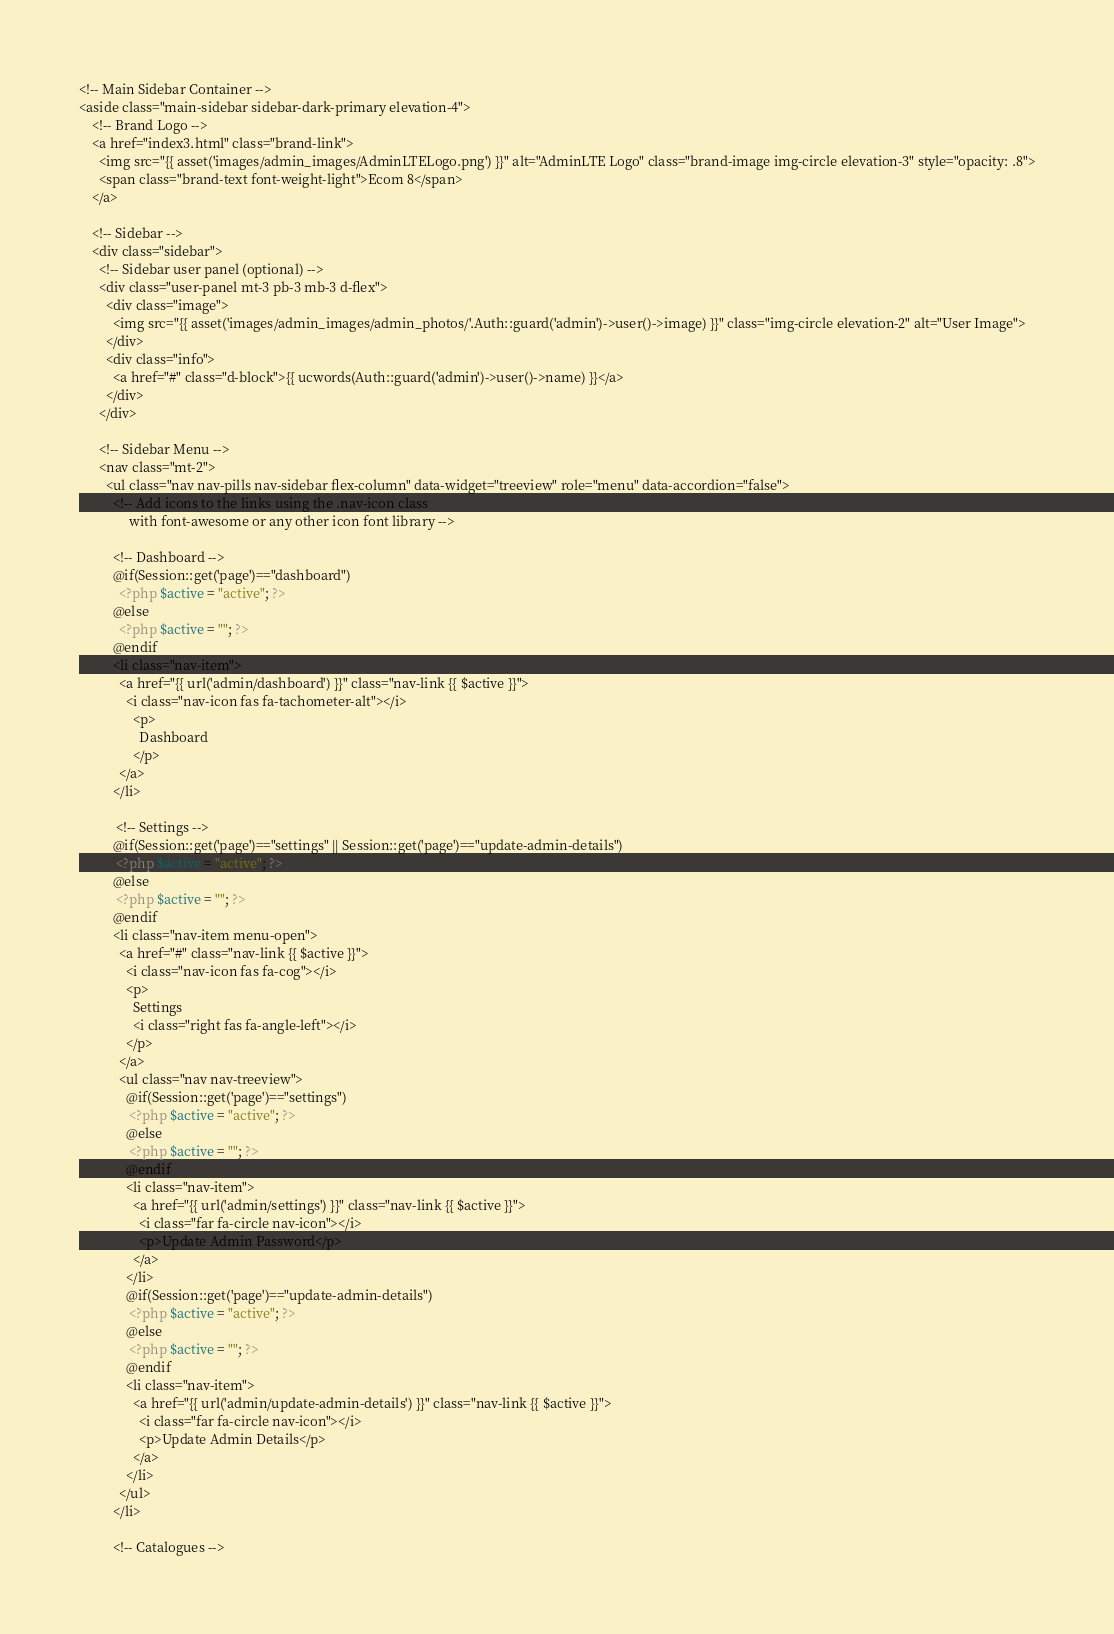<code> <loc_0><loc_0><loc_500><loc_500><_PHP_><!-- Main Sidebar Container -->
<aside class="main-sidebar sidebar-dark-primary elevation-4">
    <!-- Brand Logo -->
    <a href="index3.html" class="brand-link">
      <img src="{{ asset('images/admin_images/AdminLTELogo.png') }}" alt="AdminLTE Logo" class="brand-image img-circle elevation-3" style="opacity: .8">
      <span class="brand-text font-weight-light">Ecom 8</span>
    </a>

    <!-- Sidebar -->
    <div class="sidebar">
      <!-- Sidebar user panel (optional) -->
      <div class="user-panel mt-3 pb-3 mb-3 d-flex">
        <div class="image">
          <img src="{{ asset('images/admin_images/admin_photos/'.Auth::guard('admin')->user()->image) }}" class="img-circle elevation-2" alt="User Image">
        </div>
        <div class="info">
          <a href="#" class="d-block">{{ ucwords(Auth::guard('admin')->user()->name) }}</a>
        </div>
      </div>

      <!-- Sidebar Menu -->
      <nav class="mt-2">
        <ul class="nav nav-pills nav-sidebar flex-column" data-widget="treeview" role="menu" data-accordion="false">
          <!-- Add icons to the links using the .nav-icon class
               with font-awesome or any other icon font library -->

          <!-- Dashboard -->     
          @if(Session::get('page')=="dashboard")
            <?php $active = "active"; ?>
          @else
            <?php $active = ""; ?>
          @endif     
          <li class="nav-item">
            <a href="{{ url('admin/dashboard') }}" class="nav-link {{ $active }}">
              <i class="nav-icon fas fa-tachometer-alt"></i>
                <p>
                  Dashboard
                </p>
            </a>
          </li> 
          
           <!-- Settings -->
          @if(Session::get('page')=="settings" || Session::get('page')=="update-admin-details")
           <?php $active = "active"; ?>
          @else
           <?php $active = ""; ?>
          @endif   
          <li class="nav-item menu-open">
            <a href="#" class="nav-link {{ $active }}">
              <i class="nav-icon fas fa-cog"></i>
              <p>
                Settings
                <i class="right fas fa-angle-left"></i>
              </p>
            </a>
            <ul class="nav nav-treeview">
              @if(Session::get('page')=="settings")
               <?php $active = "active"; ?>
              @else
               <?php $active = ""; ?>
              @endif  
              <li class="nav-item">
                <a href="{{ url('admin/settings') }}" class="nav-link {{ $active }}">
                  <i class="far fa-circle nav-icon"></i>
                  <p>Update Admin Password</p>
                </a>
              </li>
              @if(Session::get('page')=="update-admin-details")
               <?php $active = "active"; ?>
              @else
               <?php $active = ""; ?>
              @endif  
              <li class="nav-item">
                <a href="{{ url('admin/update-admin-details') }}" class="nav-link {{ $active }}">
                  <i class="far fa-circle nav-icon"></i>
                  <p>Update Admin Details</p>
                </a>
              </li>
            </ul>
          </li>
         
          <!-- Catalogues --></code> 